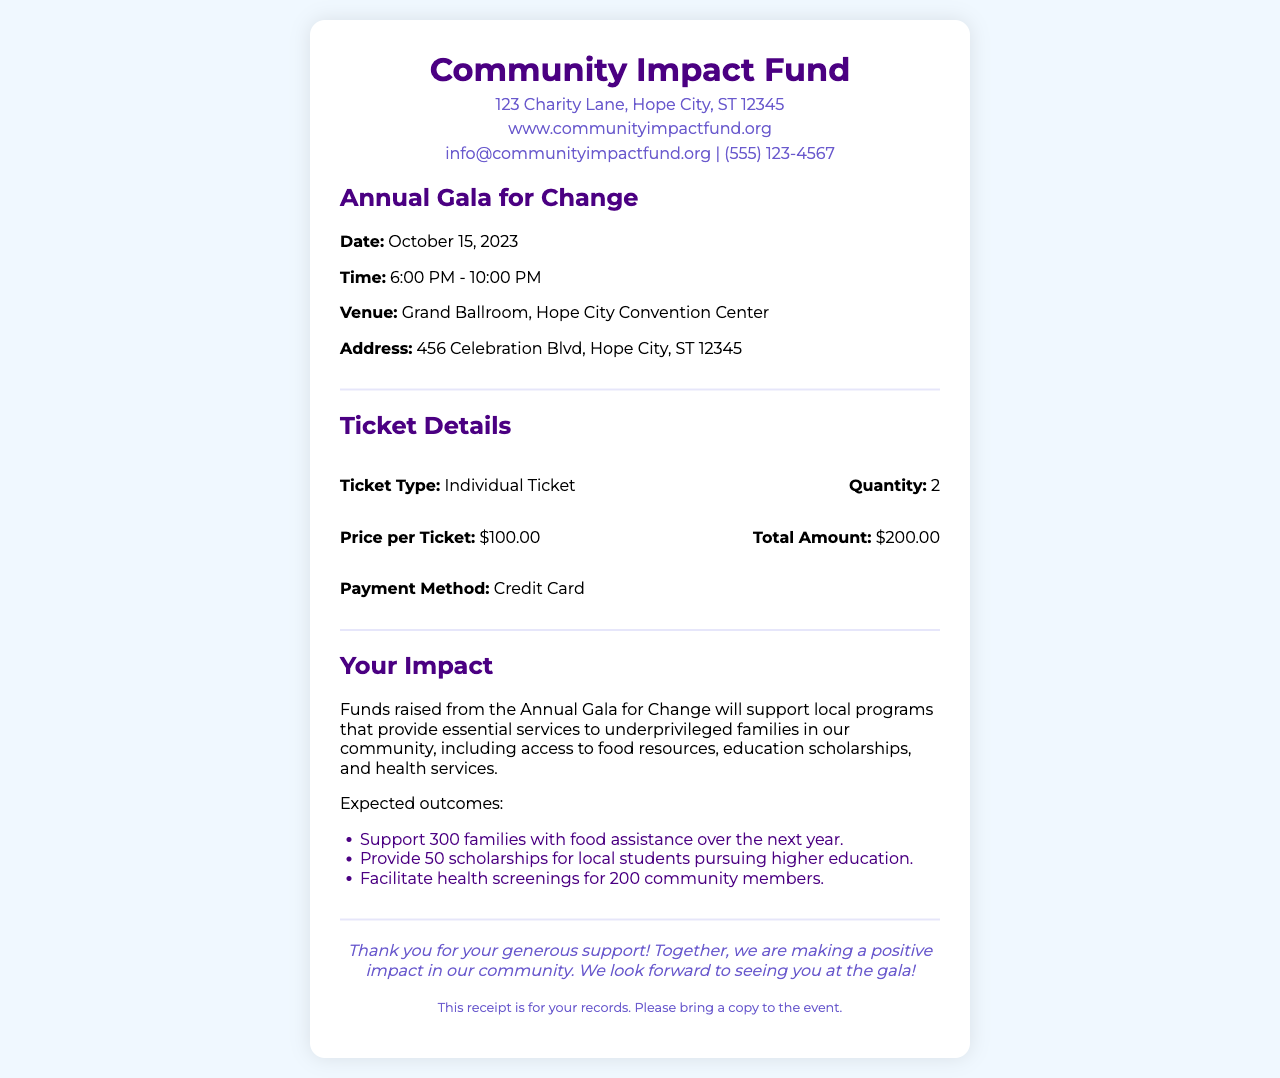what is the name of the event? The name of the event is clearly stated in the document's header section.
Answer: Annual Gala for Change what is the date of the gala? The date is provided in the event details section of the document.
Answer: October 15, 2023 how many tickets were purchased? The quantity of tickets is mentioned in the ticket details section.
Answer: 2 what is the total amount paid for the tickets? The total amount is specified in the ticket details section.
Answer: $200.00 what is the venue of the event? The venue is provided in the event details section of the document.
Answer: Grand Ballroom, Hope City Convention Center what is the expected support for families in the community? The expected outcome regarding families is mentioned in the impact section of the document.
Answer: Support 300 families with food assistance over the next year what kind of scholarships will be provided? The document lists the type of scholarships in the impact section.
Answer: Education scholarships how many health screenings are expected to be facilitated? The expected number of health screenings is found in the impact section of the document.
Answer: 200 community members what is the payment method used? The payment method is stated in the ticket details section of the document.
Answer: Credit Card 